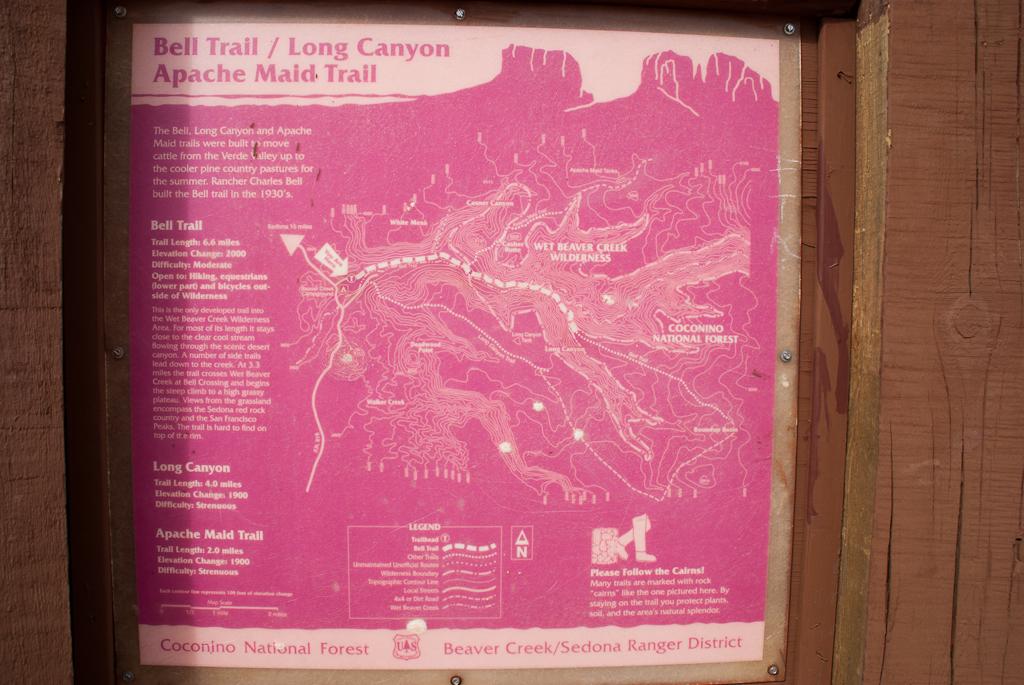What canyon is talked about here?
Offer a terse response. Long canyon. What canyon is mentioned?
Your answer should be very brief. Long canyon. 